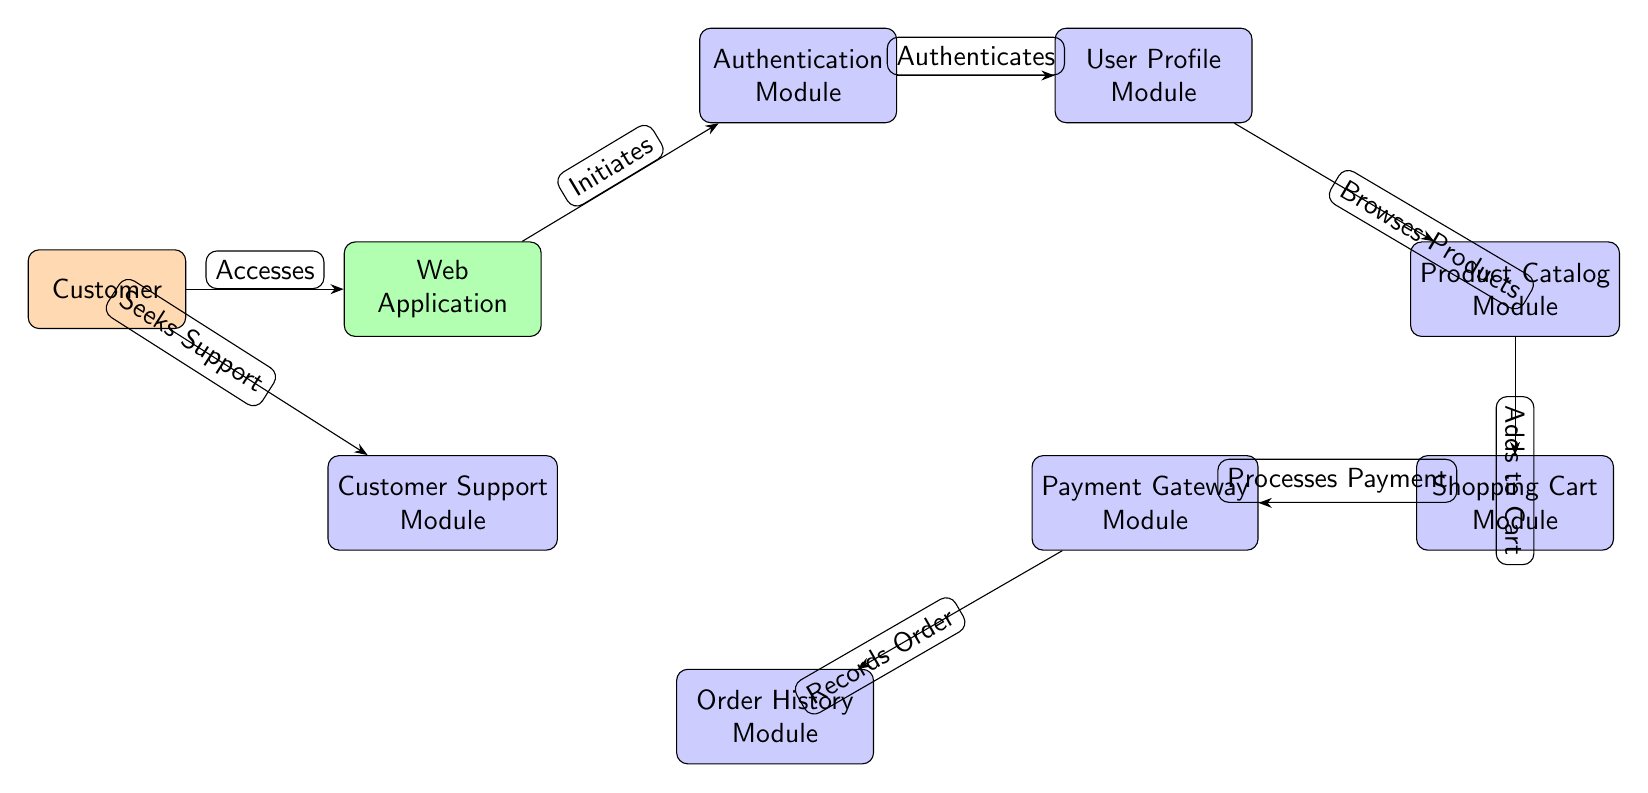What is the first module the customer interacts with? The customer first accesses the Web Application, which then initiates the Authentication Module. The Authentication Module is the first module in the pathway after the Web Application.
Answer: Authentication Module How many modules are connected to the Shopping Cart Module? The Shopping Cart Module has two outgoing connections: one to the Payment Gateway Module and one to the Product Catalog Module. Therefore, it is connected to two modules.
Answer: 2 What action does the customer take to seek assistance? The customer seeks support by connecting directly to the Customer Support Module. This action is indicated in the diagram as an edge from the Customer to the Support Module labeled 'Seeks Support'.
Answer: Seeks Support Which module does the User Profile Module authenticate with? The User Profile Module is authenticated by the Authentication Module, which directly connects to it in the diagram. Thus, it is the module responsible for the authentication process for the User Profile Module.
Answer: Authentication Module What are the last two modules in the interaction pathway after the customer browses products? After browsing products in the Product Catalog Module, the customer adds items to the Shopping Cart Module, which then leads to the Payment Gateway Module. These are the last two modules in the pathway.
Answer: Shopping Cart Module, Payment Gateway Module Which module records the order following the payment process? The Order History Module records the order after the Payment Gateway Module processes the payment. The diagram indicates that there is a direct link from the Payment Gateway Module to the Order History Module.
Answer: Order History Module How many total modules are represented in the diagram? Counting all the modules in the diagram, we have seven modules: Authentication Module, User Profile Module, Product Catalog Module, Shopping Cart Module, Payment Gateway Module, Order History Module, and Customer Support Module. Therefore, the total count is seven.
Answer: 7 What is the relationship between the Product Catalog Module and the Shopping Cart Module? The relationship is that products are added to the Shopping Cart Module from the Product Catalog Module, indicated by the directed edge labeled 'Adds to Cart'. This clearly defines their interaction.
Answer: Adds to Cart Which module does the customer access first? The customer accesses the Web Application first, which is the starting point of their interaction pathway according to the diagram.
Answer: Web Application 